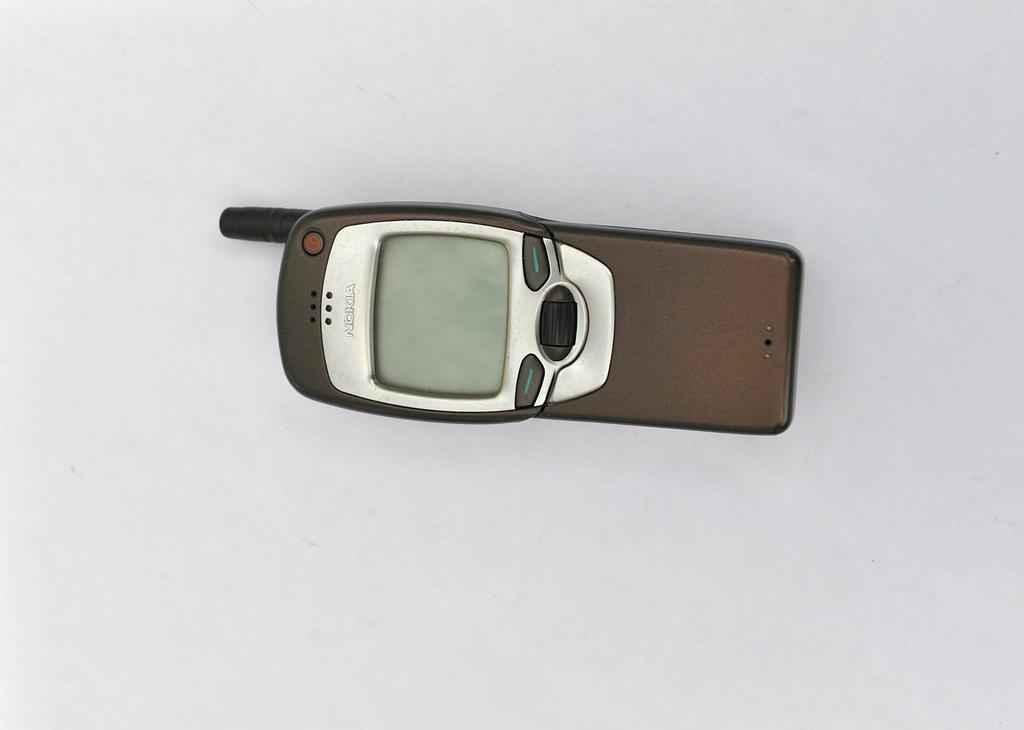What is the brand of phone?
Offer a terse response. Nokia. 